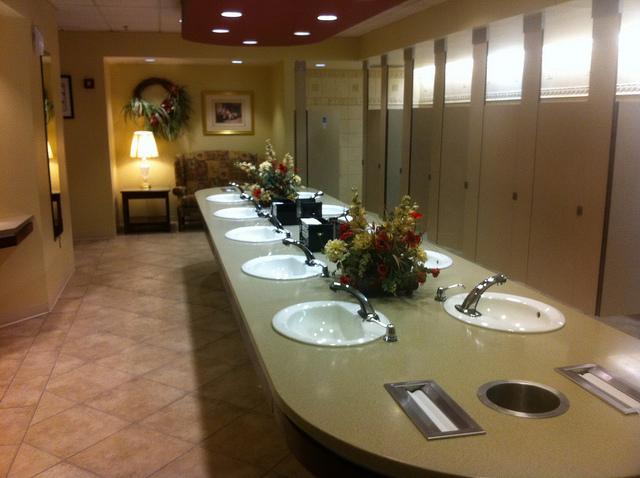What is on the wall above the lamp?
Quick response, please. Wreath. Is this a restroom for a large company?
Be succinct. Yes. Are there any flowers in the bathroom?
Short answer required. Yes. 